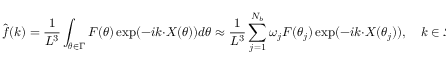<formula> <loc_0><loc_0><loc_500><loc_500>\hat { \boldsymbol f } ( \boldsymbol k ) = \frac { 1 } { L ^ { 3 } } \int _ { \boldsymbol \theta \in \Gamma } \boldsymbol F ( \boldsymbol \theta ) \exp ( - i \boldsymbol k \cdot \boldsymbol X ( \boldsymbol \theta ) ) d \boldsymbol \theta \approx \frac { 1 } { L ^ { 3 } } \sum _ { j = 1 } ^ { N _ { b } } \omega _ { j } \boldsymbol F ( \boldsymbol \theta _ { j } ) \exp ( - i \boldsymbol k \cdot \boldsymbol X ( \boldsymbol \theta _ { j } ) ) , \quad \boldsymbol k \in \mathcal { K } _ { N } ,</formula> 